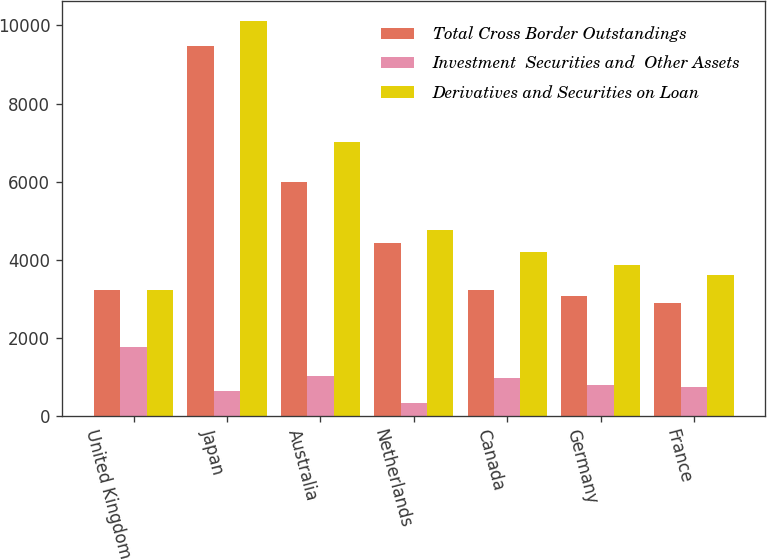Convert chart. <chart><loc_0><loc_0><loc_500><loc_500><stacked_bar_chart><ecel><fcel>United Kingdom<fcel>Japan<fcel>Australia<fcel>Netherlands<fcel>Canada<fcel>Germany<fcel>France<nl><fcel>Total Cross Border Outstandings<fcel>3227<fcel>9465<fcel>5981<fcel>4425<fcel>3227<fcel>3075<fcel>2887<nl><fcel>Investment  Securities and  Other Assets<fcel>1769<fcel>644<fcel>1039<fcel>330<fcel>974<fcel>792<fcel>735<nl><fcel>Derivatives and Securities on Loan<fcel>3227<fcel>10109<fcel>7020<fcel>4755<fcel>4201<fcel>3867<fcel>3622<nl></chart> 